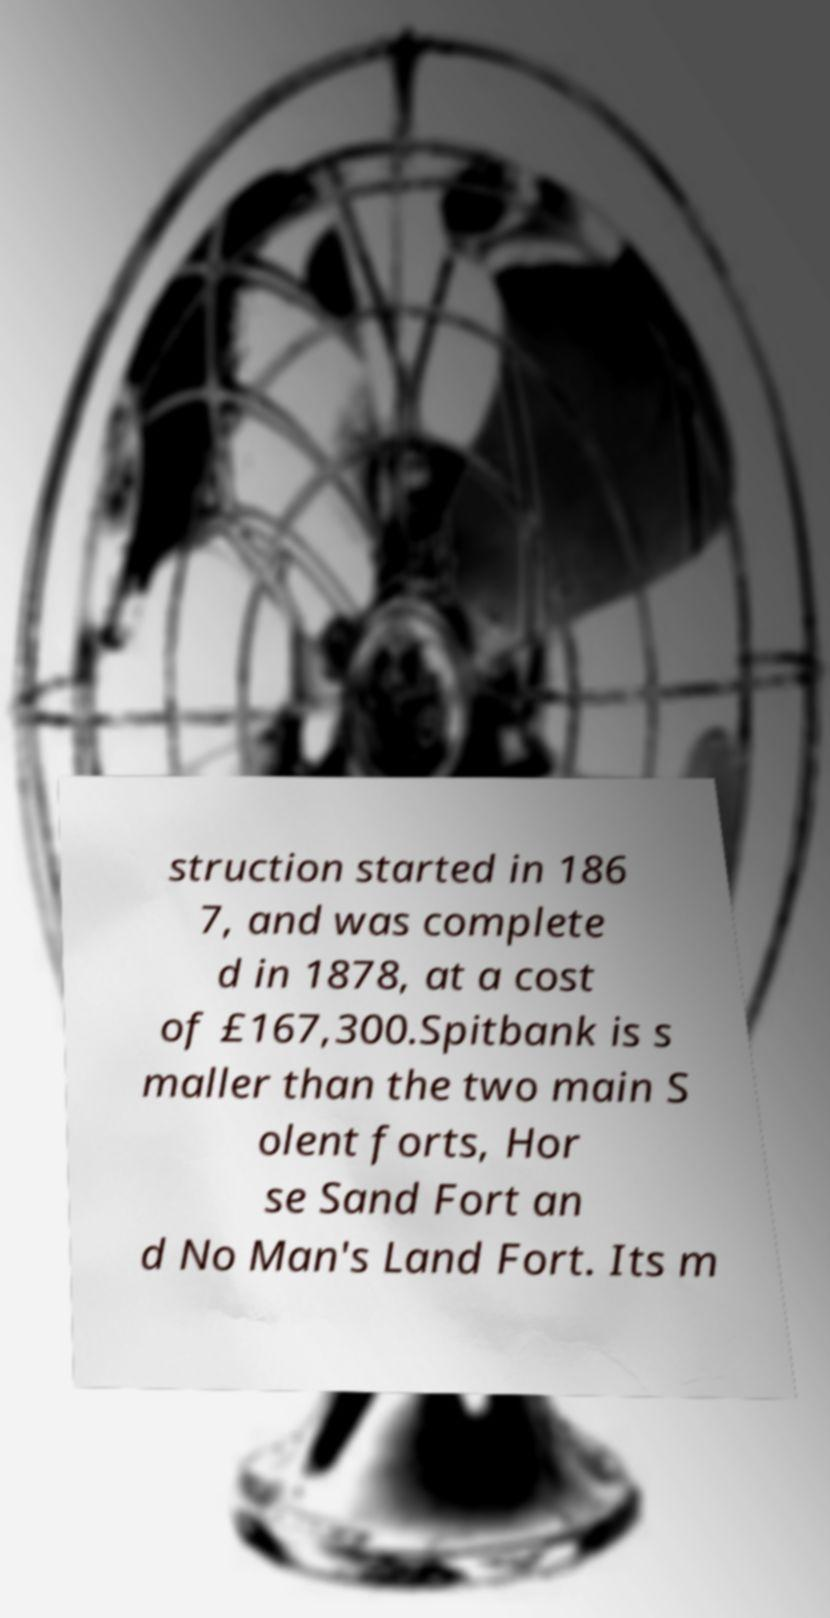For documentation purposes, I need the text within this image transcribed. Could you provide that? struction started in 186 7, and was complete d in 1878, at a cost of £167,300.Spitbank is s maller than the two main S olent forts, Hor se Sand Fort an d No Man's Land Fort. Its m 